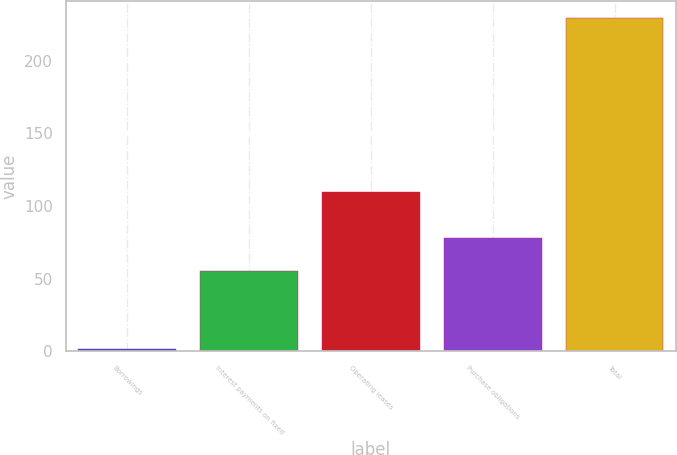Convert chart to OTSL. <chart><loc_0><loc_0><loc_500><loc_500><bar_chart><fcel>Borrowings<fcel>Interest payments on fixed<fcel>Operating leases<fcel>Purchase obligations<fcel>Total<nl><fcel>1.5<fcel>55.2<fcel>109.7<fcel>77.98<fcel>229.3<nl></chart> 